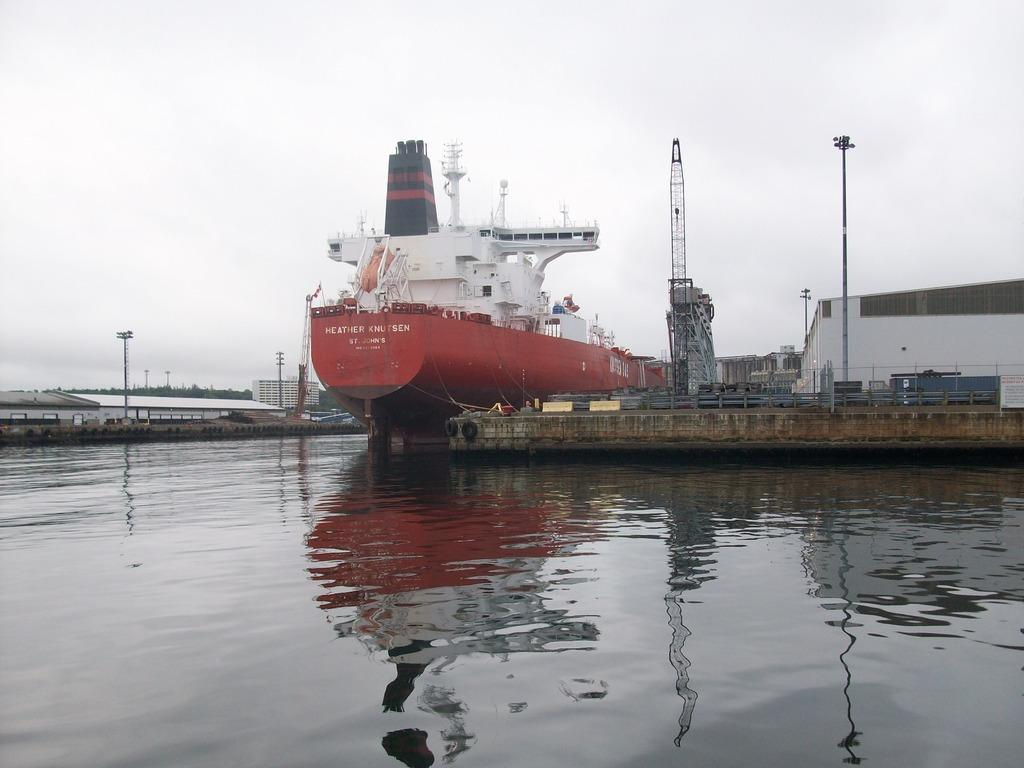<image>
Render a clear and concise summary of the photo. The ship Heather Knutsen sits at the dock on a gray day. 